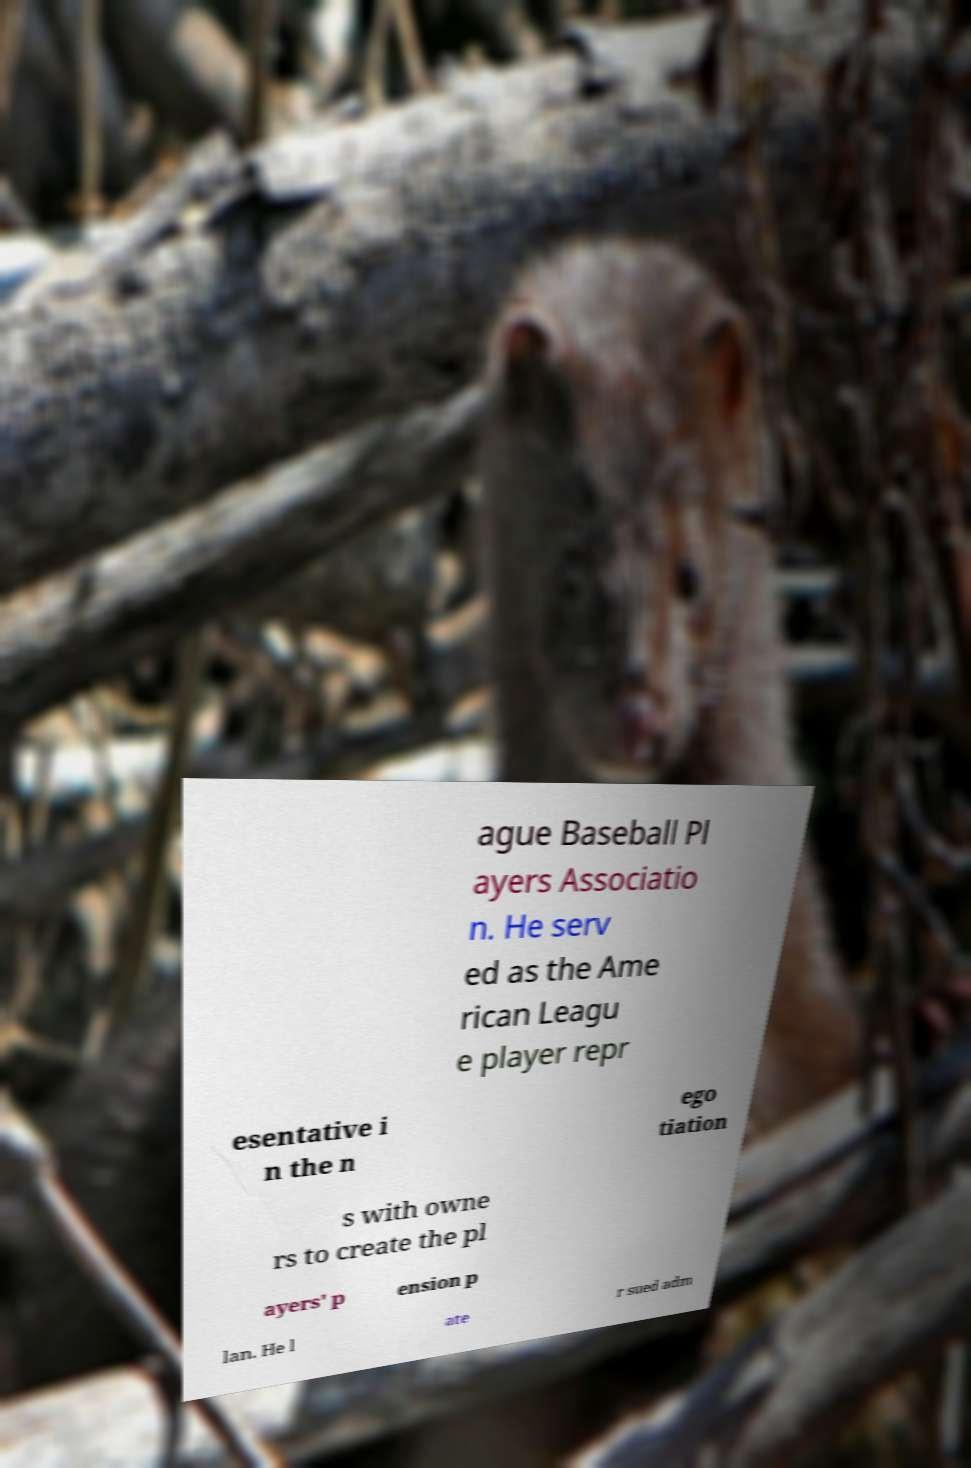Can you accurately transcribe the text from the provided image for me? ague Baseball Pl ayers Associatio n. He serv ed as the Ame rican Leagu e player repr esentative i n the n ego tiation s with owne rs to create the pl ayers' p ension p lan. He l ate r sued adm 